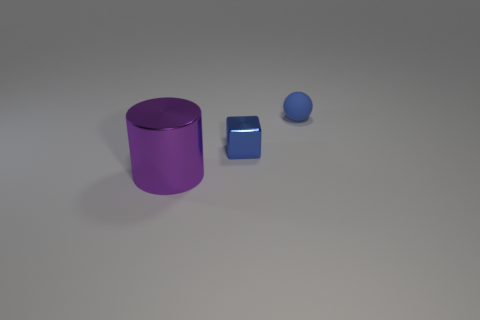Add 3 large blue cubes. How many objects exist? 6 Subtract all cubes. How many objects are left? 2 Subtract 0 gray balls. How many objects are left? 3 Subtract all blue matte objects. Subtract all yellow spheres. How many objects are left? 2 Add 3 large purple metallic objects. How many large purple metallic objects are left? 4 Add 1 tiny gray rubber balls. How many tiny gray rubber balls exist? 1 